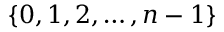Convert formula to latex. <formula><loc_0><loc_0><loc_500><loc_500>\{ 0 , 1 , 2 , \dots , n - 1 \}</formula> 